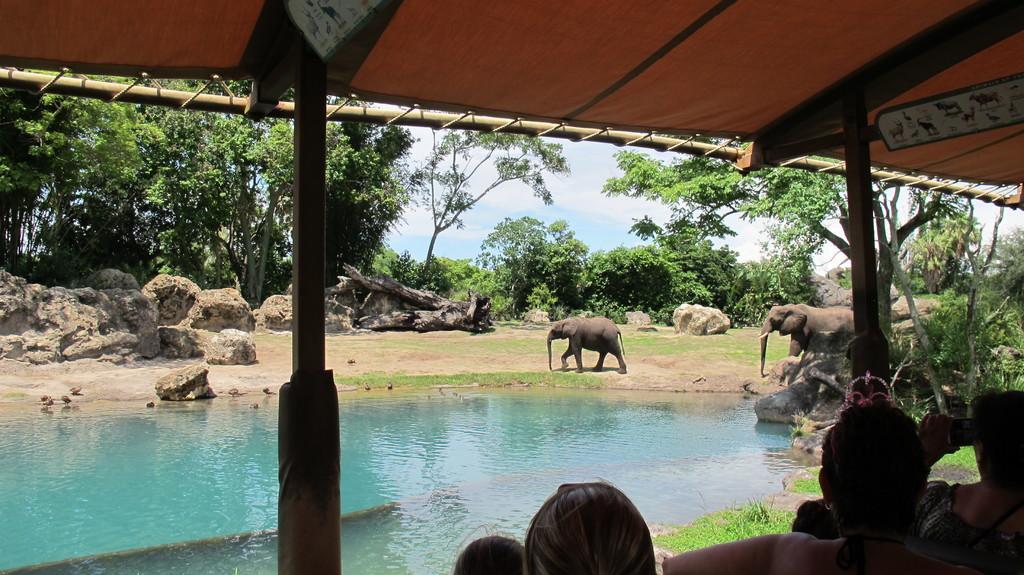Describe this image in one or two sentences. In the image we can see there are two elephants, there are the stones, trees, sky, water, grass and there are people wearing clothes. This is a pole and this is a tent. 